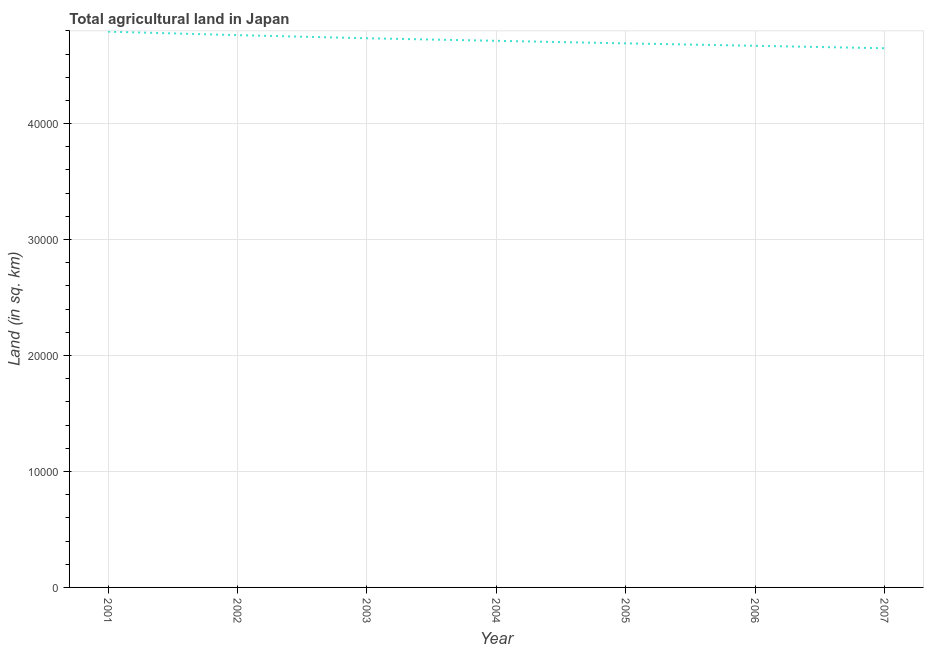What is the agricultural land in 2007?
Offer a terse response. 4.65e+04. Across all years, what is the maximum agricultural land?
Your response must be concise. 4.79e+04. Across all years, what is the minimum agricultural land?
Provide a short and direct response. 4.65e+04. In which year was the agricultural land maximum?
Provide a short and direct response. 2001. In which year was the agricultural land minimum?
Your answer should be very brief. 2007. What is the sum of the agricultural land?
Your response must be concise. 3.30e+05. What is the difference between the agricultural land in 2004 and 2006?
Keep it short and to the point. 430. What is the average agricultural land per year?
Provide a succinct answer. 4.72e+04. What is the median agricultural land?
Give a very brief answer. 4.71e+04. In how many years, is the agricultural land greater than 38000 sq. km?
Offer a very short reply. 7. What is the ratio of the agricultural land in 2004 to that in 2007?
Ensure brevity in your answer.  1.01. Is the agricultural land in 2003 less than that in 2004?
Make the answer very short. No. What is the difference between the highest and the second highest agricultural land?
Give a very brief answer. 300. What is the difference between the highest and the lowest agricultural land?
Ensure brevity in your answer.  1430. In how many years, is the agricultural land greater than the average agricultural land taken over all years?
Offer a terse response. 3. Does the agricultural land monotonically increase over the years?
Provide a short and direct response. No. How many lines are there?
Give a very brief answer. 1. What is the title of the graph?
Give a very brief answer. Total agricultural land in Japan. What is the label or title of the X-axis?
Ensure brevity in your answer.  Year. What is the label or title of the Y-axis?
Ensure brevity in your answer.  Land (in sq. km). What is the Land (in sq. km) of 2001?
Make the answer very short. 4.79e+04. What is the Land (in sq. km) in 2002?
Give a very brief answer. 4.76e+04. What is the Land (in sq. km) in 2003?
Give a very brief answer. 4.74e+04. What is the Land (in sq. km) in 2004?
Ensure brevity in your answer.  4.71e+04. What is the Land (in sq. km) of 2005?
Your answer should be very brief. 4.69e+04. What is the Land (in sq. km) in 2006?
Ensure brevity in your answer.  4.67e+04. What is the Land (in sq. km) of 2007?
Keep it short and to the point. 4.65e+04. What is the difference between the Land (in sq. km) in 2001 and 2002?
Offer a terse response. 300. What is the difference between the Land (in sq. km) in 2001 and 2003?
Make the answer very short. 570. What is the difference between the Land (in sq. km) in 2001 and 2004?
Give a very brief answer. 790. What is the difference between the Land (in sq. km) in 2001 and 2005?
Ensure brevity in your answer.  1010. What is the difference between the Land (in sq. km) in 2001 and 2006?
Your answer should be compact. 1220. What is the difference between the Land (in sq. km) in 2001 and 2007?
Provide a short and direct response. 1430. What is the difference between the Land (in sq. km) in 2002 and 2003?
Provide a succinct answer. 270. What is the difference between the Land (in sq. km) in 2002 and 2004?
Your response must be concise. 490. What is the difference between the Land (in sq. km) in 2002 and 2005?
Offer a very short reply. 710. What is the difference between the Land (in sq. km) in 2002 and 2006?
Your answer should be compact. 920. What is the difference between the Land (in sq. km) in 2002 and 2007?
Provide a short and direct response. 1130. What is the difference between the Land (in sq. km) in 2003 and 2004?
Your answer should be very brief. 220. What is the difference between the Land (in sq. km) in 2003 and 2005?
Provide a succinct answer. 440. What is the difference between the Land (in sq. km) in 2003 and 2006?
Give a very brief answer. 650. What is the difference between the Land (in sq. km) in 2003 and 2007?
Ensure brevity in your answer.  860. What is the difference between the Land (in sq. km) in 2004 and 2005?
Make the answer very short. 220. What is the difference between the Land (in sq. km) in 2004 and 2006?
Make the answer very short. 430. What is the difference between the Land (in sq. km) in 2004 and 2007?
Your response must be concise. 640. What is the difference between the Land (in sq. km) in 2005 and 2006?
Keep it short and to the point. 210. What is the difference between the Land (in sq. km) in 2005 and 2007?
Your response must be concise. 420. What is the difference between the Land (in sq. km) in 2006 and 2007?
Offer a very short reply. 210. What is the ratio of the Land (in sq. km) in 2001 to that in 2006?
Offer a terse response. 1.03. What is the ratio of the Land (in sq. km) in 2001 to that in 2007?
Your answer should be compact. 1.03. What is the ratio of the Land (in sq. km) in 2002 to that in 2006?
Make the answer very short. 1.02. What is the ratio of the Land (in sq. km) in 2002 to that in 2007?
Your response must be concise. 1.02. What is the ratio of the Land (in sq. km) in 2003 to that in 2004?
Your answer should be compact. 1. What is the ratio of the Land (in sq. km) in 2003 to that in 2006?
Your answer should be very brief. 1.01. What is the ratio of the Land (in sq. km) in 2003 to that in 2007?
Your response must be concise. 1.02. What is the ratio of the Land (in sq. km) in 2004 to that in 2005?
Make the answer very short. 1. What is the ratio of the Land (in sq. km) in 2004 to that in 2006?
Make the answer very short. 1.01. What is the ratio of the Land (in sq. km) in 2005 to that in 2006?
Offer a terse response. 1. What is the ratio of the Land (in sq. km) in 2005 to that in 2007?
Give a very brief answer. 1.01. 